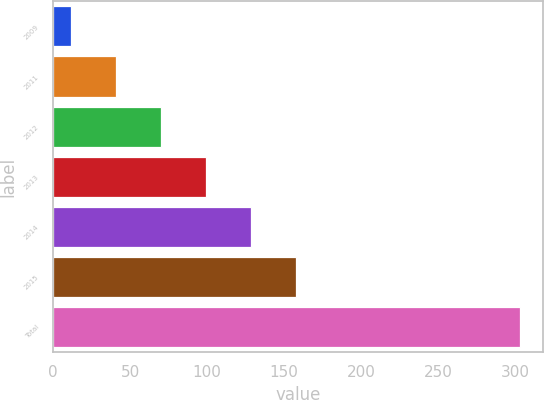Convert chart. <chart><loc_0><loc_0><loc_500><loc_500><bar_chart><fcel>2009<fcel>2011<fcel>2012<fcel>2013<fcel>2014<fcel>2015<fcel>Total<nl><fcel>12<fcel>41.1<fcel>70.2<fcel>99.3<fcel>128.4<fcel>157.5<fcel>303<nl></chart> 